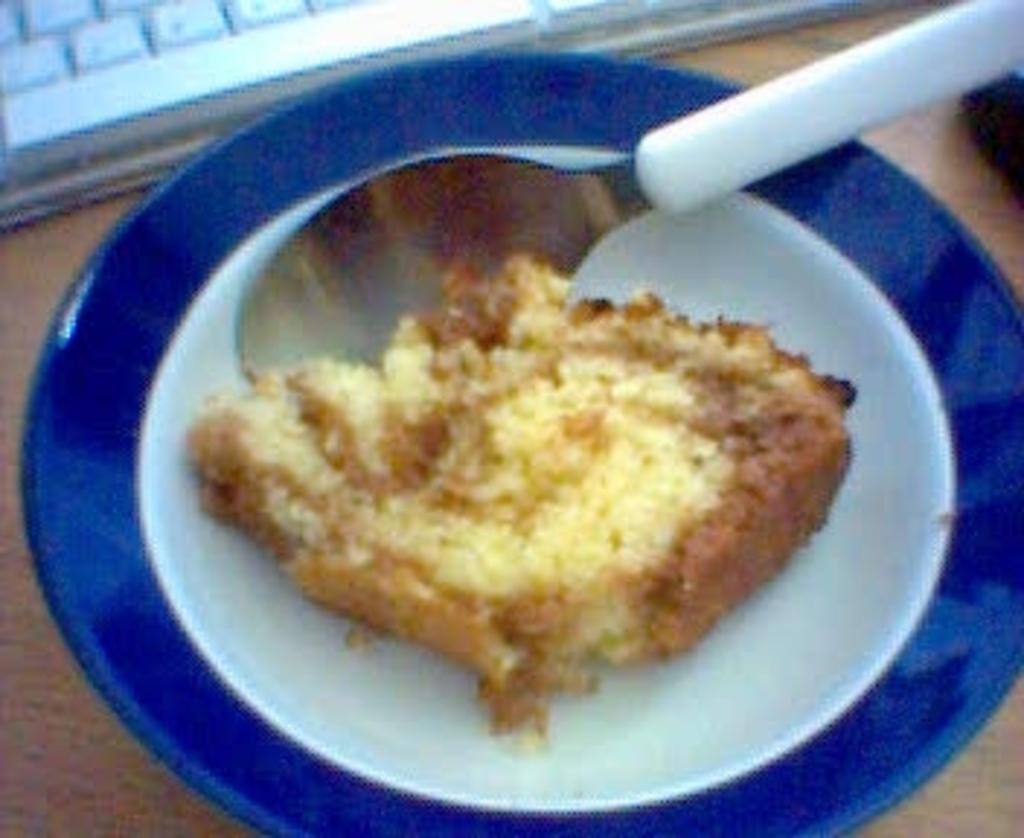Describe this image in one or two sentences. In this image we can see food item and a spoon on a plate. The plate is placed on a wooden surface. At the top we can see a keyboard. 